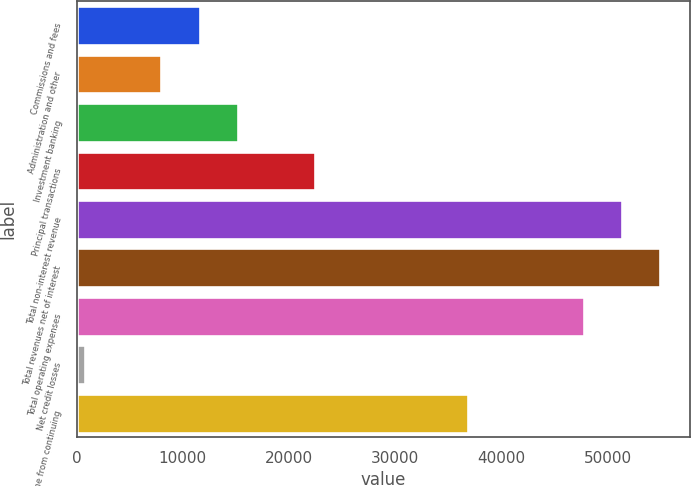Convert chart to OTSL. <chart><loc_0><loc_0><loc_500><loc_500><bar_chart><fcel>Commissions and fees<fcel>Administration and other<fcel>Investment banking<fcel>Principal transactions<fcel>Total non-interest revenue<fcel>Total revenues net of interest<fcel>Total operating expenses<fcel>Net credit losses<fcel>Income from continuing<nl><fcel>11590.9<fcel>7975.6<fcel>15206.2<fcel>22436.8<fcel>51359.2<fcel>54974.5<fcel>47743.9<fcel>745<fcel>36898<nl></chart> 